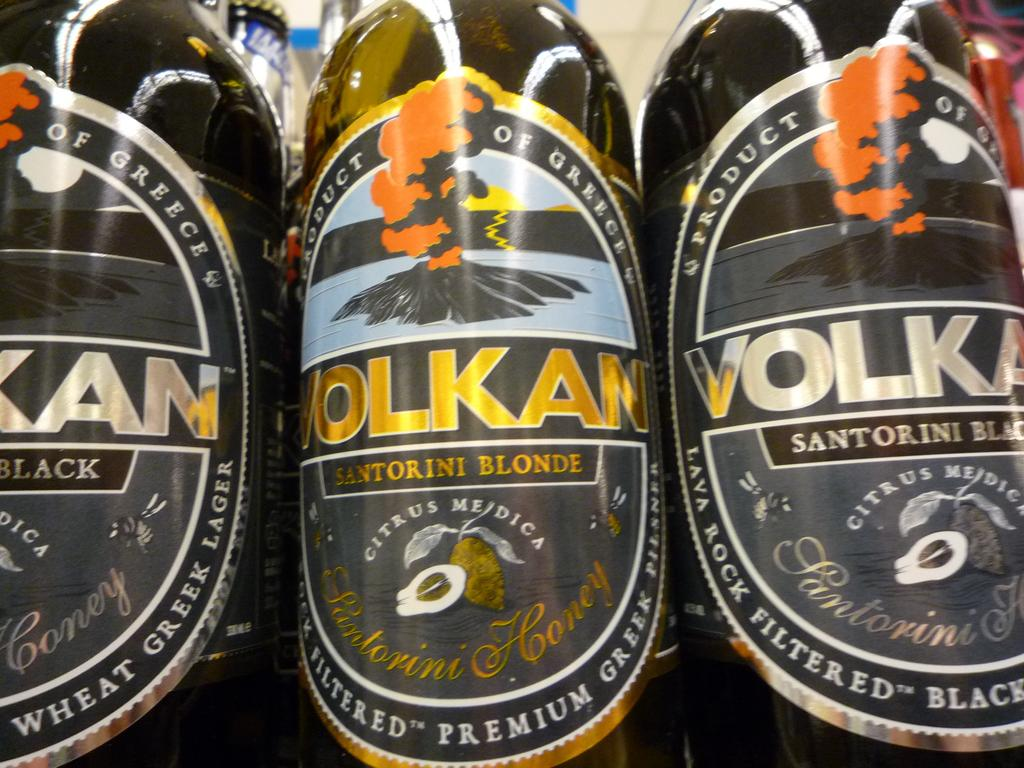How many black bottles are in the image? There are three black bottles in the image. What distinguishes the labels on the bottles? The labels on the bottles have different colors: orange, white, and golden. What type of hair can be seen on the duck in the image? There is no duck present in the image, and therefore no hair can be observed. What organization is responsible for the bottles in the image? The provided facts do not mention any organization responsible for the bottles, so it cannot be determined from the image. 